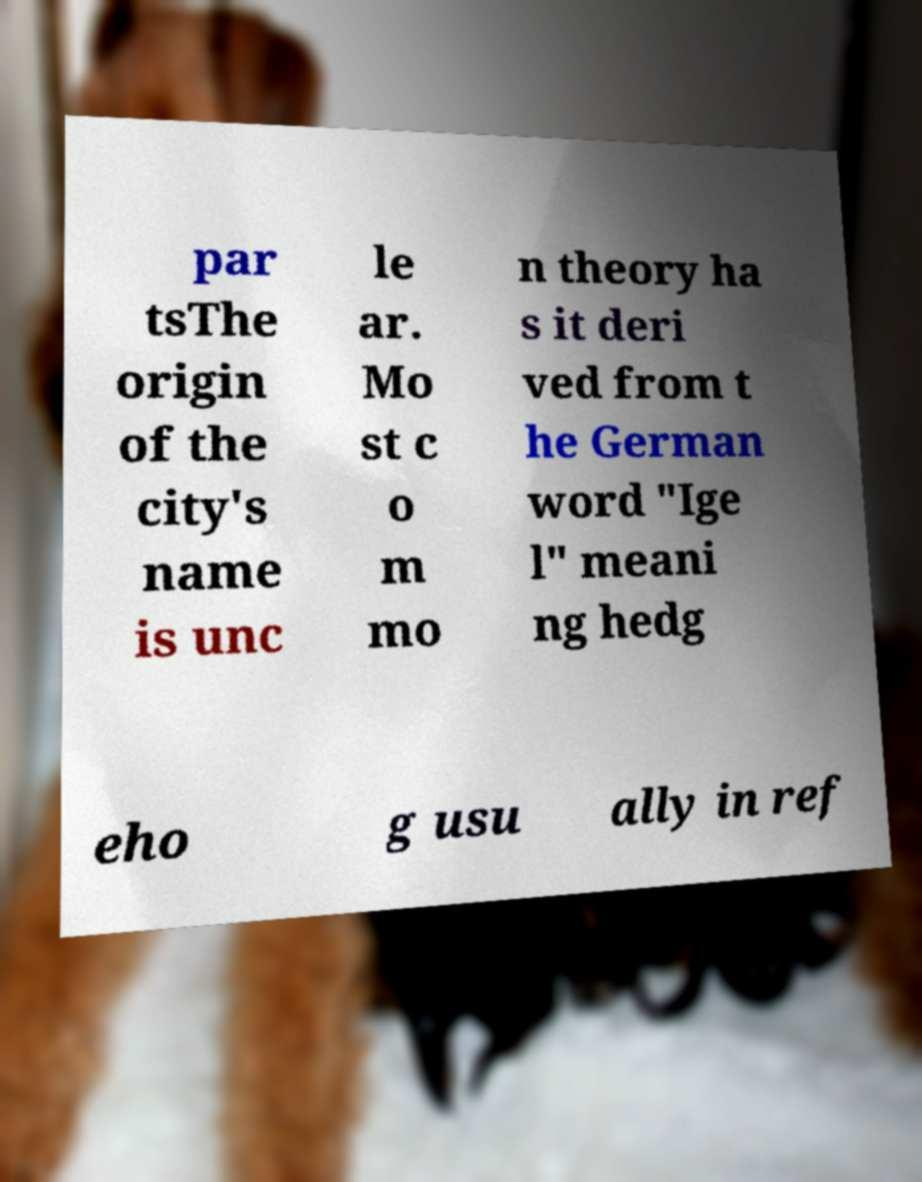For documentation purposes, I need the text within this image transcribed. Could you provide that? par tsThe origin of the city's name is unc le ar. Mo st c o m mo n theory ha s it deri ved from t he German word "Ige l" meani ng hedg eho g usu ally in ref 